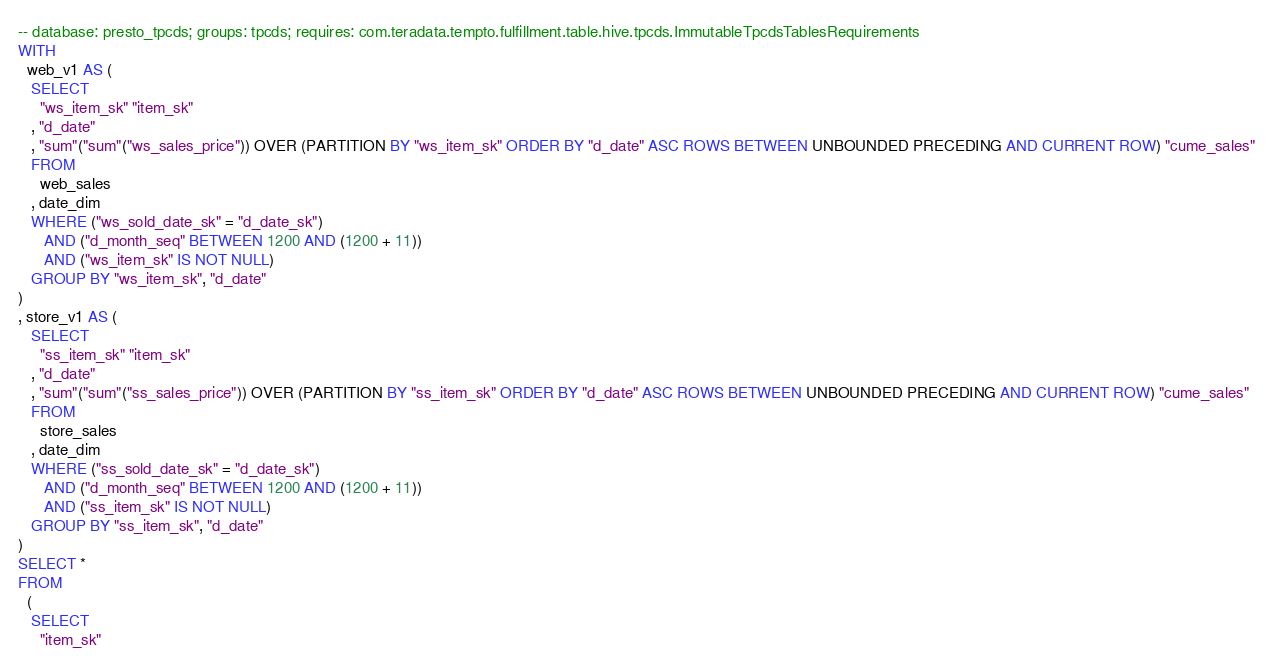<code> <loc_0><loc_0><loc_500><loc_500><_SQL_>-- database: presto_tpcds; groups: tpcds; requires: com.teradata.tempto.fulfillment.table.hive.tpcds.ImmutableTpcdsTablesRequirements
WITH
  web_v1 AS (
   SELECT
     "ws_item_sk" "item_sk"
   , "d_date"
   , "sum"("sum"("ws_sales_price")) OVER (PARTITION BY "ws_item_sk" ORDER BY "d_date" ASC ROWS BETWEEN UNBOUNDED PRECEDING AND CURRENT ROW) "cume_sales"
   FROM
     web_sales
   , date_dim
   WHERE ("ws_sold_date_sk" = "d_date_sk")
      AND ("d_month_seq" BETWEEN 1200 AND (1200 + 11))
      AND ("ws_item_sk" IS NOT NULL)
   GROUP BY "ws_item_sk", "d_date"
) 
, store_v1 AS (
   SELECT
     "ss_item_sk" "item_sk"
   , "d_date"
   , "sum"("sum"("ss_sales_price")) OVER (PARTITION BY "ss_item_sk" ORDER BY "d_date" ASC ROWS BETWEEN UNBOUNDED PRECEDING AND CURRENT ROW) "cume_sales"
   FROM
     store_sales
   , date_dim
   WHERE ("ss_sold_date_sk" = "d_date_sk")
      AND ("d_month_seq" BETWEEN 1200 AND (1200 + 11))
      AND ("ss_item_sk" IS NOT NULL)
   GROUP BY "ss_item_sk", "d_date"
) 
SELECT *
FROM
  (
   SELECT
     "item_sk"</code> 